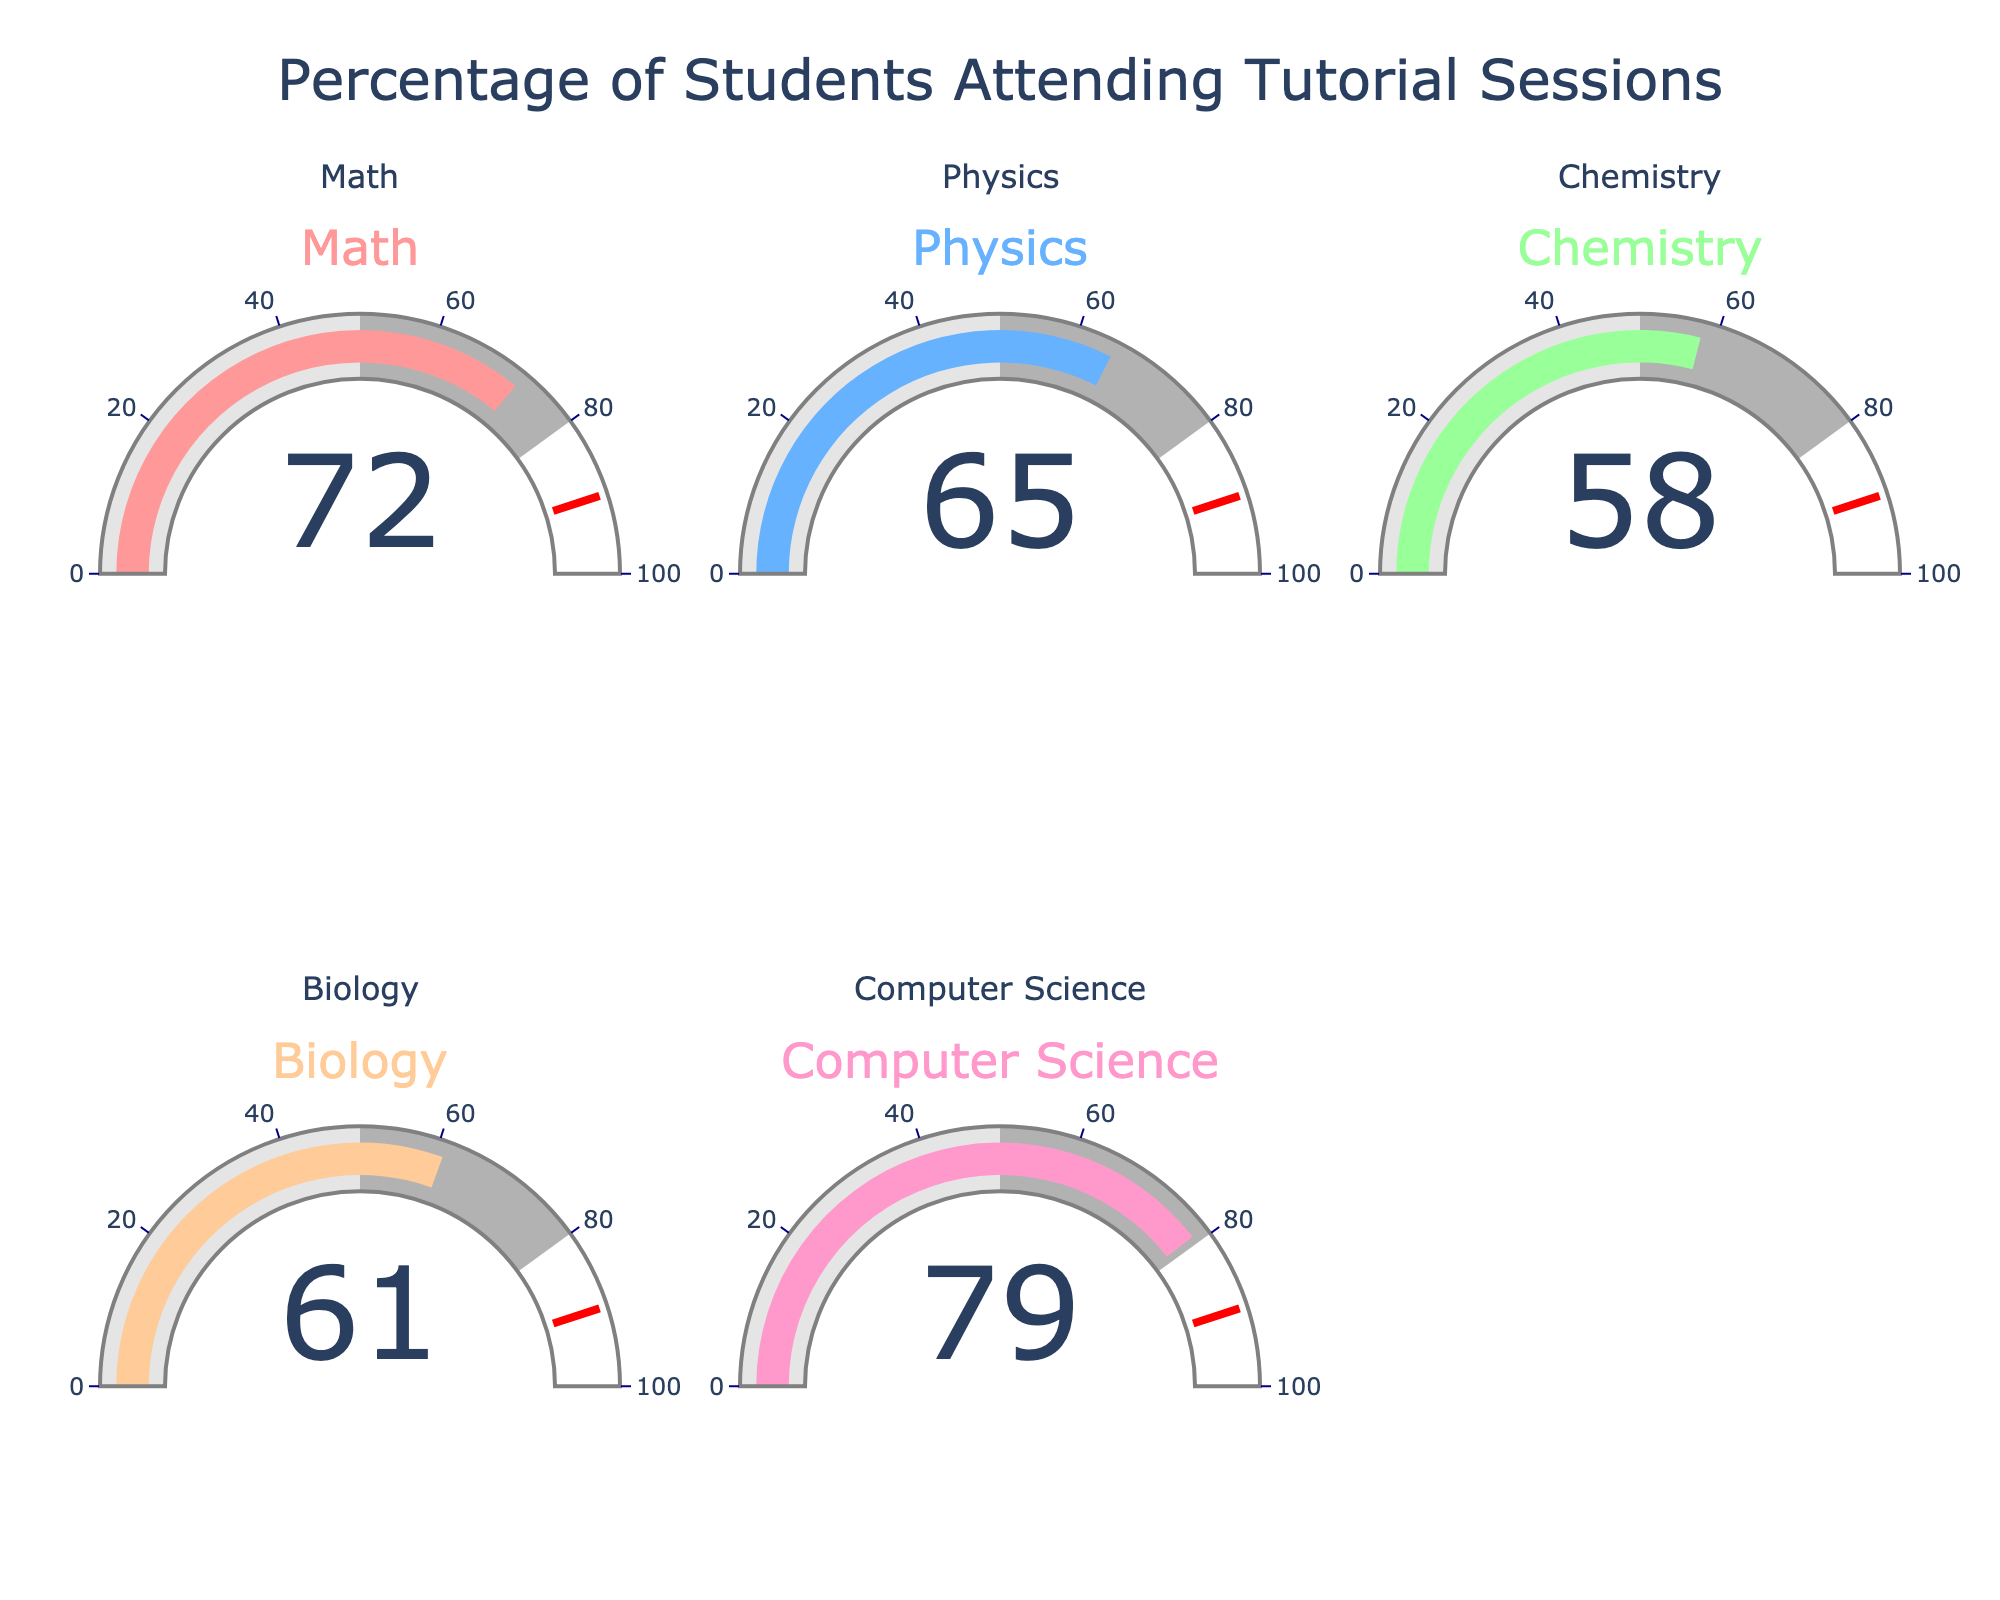what is the highest percentage of students attending tutorial sessions? The chart shows different percentages for each subject. The highest value among Math (72), Physics (65), Chemistry (58), Biology (61), and Computer Science (79) is Computer Science with 79%.
Answer: 79% Which subject has the lowest percentage of students attending tutorial sessions? By examining the percentages on the gauges, Chemistry has the lowest value at 58%.
Answer: Chemistry Calculate the average percentage of students attending tutorial sessions across all subjects. Sum the percentages (72+65+58+61+79) which equals 335, then divide by the number of subjects (5). The average is 335/5 = 67%.
Answer: 67% How much higher is the attendance percentage for Computer Science compared to Chemistry? Subtract Chemistry's percentage (58) from Computer Science's percentage (79). So, 79 - 58 = 21%.
Answer: 21% Are there any subjects where the attendance percentage is above 70%? If so, which ones? The only subjects with percentages above 70% are Math (72) and Computer Science (79).
Answer: Math, Computer Science What is the overall range of percentage values in the chart? The range is found by subtracting the lowest percentage (58 for Chemistry) from the highest percentage (79 for Computer Science). So, 79 - 58 = 21%.
Answer: 21% Which two subjects have the closest attendance percentages, and what is the difference between them? Compare the differences: Math-Physics (7), Chemistry-Biology (3), Physics-Biology (4), etc. The closest values are Chemistry (58) and Biology (61) with a difference of 3%.
Answer: Chemistry and Biology, 3% How does the threshold value of 90 relate to the percentages displayed? The gauge chart indicates a red line at the threshold value of 90. Since none of the subjects exceed this threshold, the threshold serves as a target benchmark that no subject has reached.
Answer: No subject reached 90% How many subjects have an attendance percentage below the average of 67%? From the percentages (72, 65, 58, 61, 79), the ones below 67% are Physics (65), Chemistry (58), and Biology (61). Thus, there are three subjects.
Answer: 3 